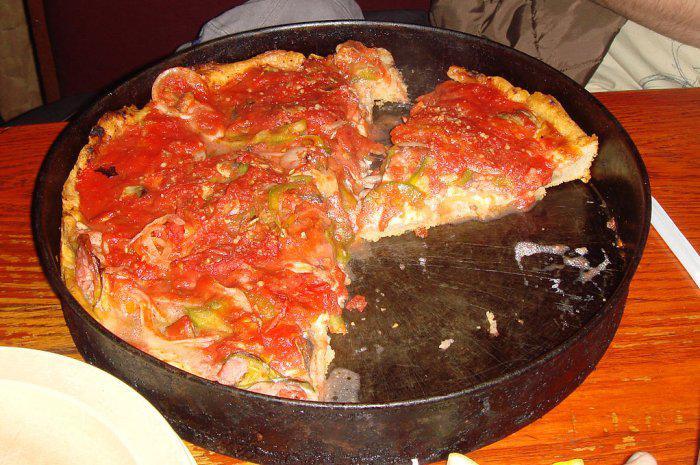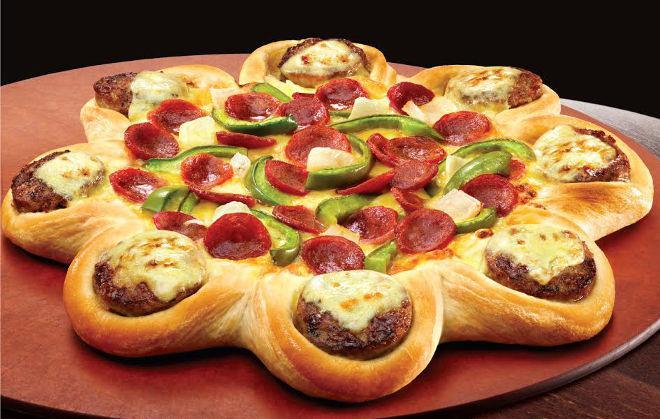The first image is the image on the left, the second image is the image on the right. Evaluate the accuracy of this statement regarding the images: "The right image shows one complete unsliced pizza with multiple hamburgers on top of it, and the left image shows a pizza with at least one slice not on its round dark pan.". Is it true? Answer yes or no. Yes. The first image is the image on the left, the second image is the image on the right. Evaluate the accuracy of this statement regarding the images: "The pizza in the image to the right has green peppers on it.". Is it true? Answer yes or no. Yes. 